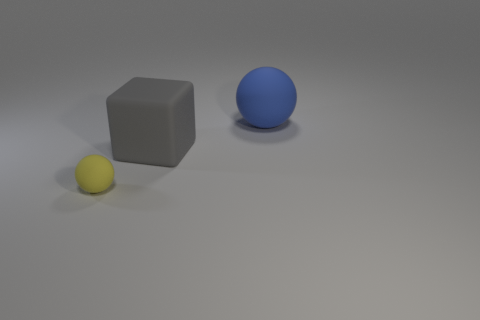Add 1 big blue rubber spheres. How many objects exist? 4 Subtract all cubes. How many objects are left? 2 Subtract all big purple cubes. Subtract all cubes. How many objects are left? 2 Add 1 tiny yellow objects. How many tiny yellow objects are left? 2 Add 3 yellow rubber things. How many yellow rubber things exist? 4 Subtract 0 green cylinders. How many objects are left? 3 